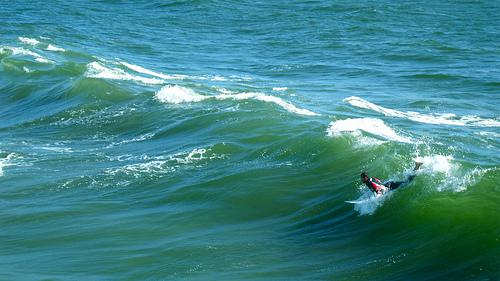Question: what is the man riding on?
Choices:
A. A scooter.
B. A bike.
C. A skateboard.
D. A surfboard.
Answer with the letter. Answer: D Question: where is this picture taken?
Choices:
A. The beach.
B. The ocean.
C. The rocks.
D. A mountain.
Answer with the letter. Answer: B 